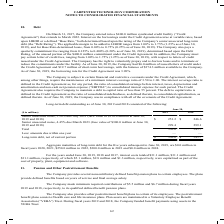According to Carpenter Technology's financial document, What were the interest costs in 2019? According to the financial document, $31.1 million. The relevant text states: "ne 30, 2019, 2018 and 2017, interest costs totaled $31.1 million, $31.1 million and $31.1 million, respectively, of which $5.1 million, $2.8 million and $1.3 millio ne 30, 2019, 2018 and 2017, interes..." Also, How is the interest coverage ratio defined? The interest coverage ratio is defined in the Credit Agreement as, for any period, the ratio of consolidated earnings before interest, taxes, depreciation and amortization and non-cash net pension expense (“EBITDA”) to consolidated interest expense for such period.. The document states: "a minimum interest coverage ratio of 3.50 to 1.00. The interest coverage ratio is defined in the Credit Agreement as, for any period, the ratio of con..." Also, In which years was the amount of long-term debt calculated? The document shows two values: 2019 and 2018. From the document: "June 30, ($ in millions) 2019 2018 Senior unsecured notes, 5.20% due July 2021 (face value of $250.0 million at June 30, 2019 and June 30, ($ in milli..." Additionally, In which year was Total debt larger? According to the financial document, 2019. The relevant text states: "June 30, ($ in millions) 2019 2018 Senior unsecured notes, 5.20% due July 2021 (face value of $250.0 million at June 30, 2019 and..." Also, can you calculate: What was the change in Total debt in 2019 from 2018? Based on the calculation: 550.6-545.7, the result is 4.9 (in millions). This is based on the information: "lion at June 30, 2019 and 2018) 299.4 299.1 Total 550.6 545.7 Less: amounts due within one year — — Long-term debt, net of current portion $ 550.6 $ 545.7 t June 30, 2019 and 2018) 299.4 299.1 Total 5..." The key data points involved are: 545.7, 550.6. Also, can you calculate: What was the percentage change in Total debt in 2019 from 2018? To answer this question, I need to perform calculations using the financial data. The calculation is: (550.6-545.7)/545.7, which equals 0.9 (percentage). This is based on the information: "lion at June 30, 2019 and 2018) 299.4 299.1 Total 550.6 545.7 Less: amounts due within one year — — Long-term debt, net of current portion $ 550.6 $ 545.7 t June 30, 2019 and 2018) 299.4 299.1 Total 5..." The key data points involved are: 545.7, 550.6. 